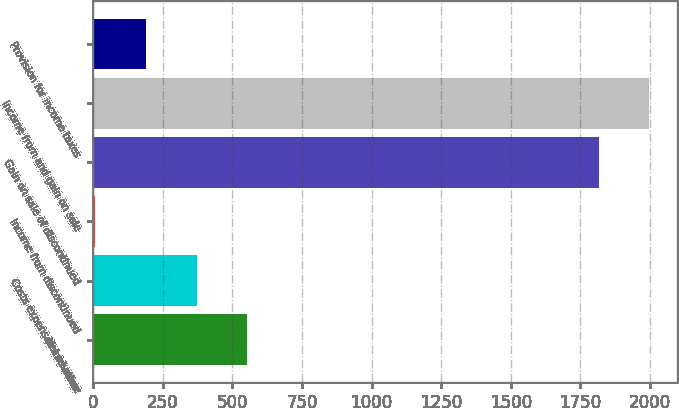Convert chart. <chart><loc_0><loc_0><loc_500><loc_500><bar_chart><fcel>Net revenue<fcel>Costs expenses and other<fcel>Income from discontinued<fcel>Gain on sale of discontinued<fcel>Income from and gain on sale<fcel>Provision for income taxes<nl><fcel>552.8<fcel>371.2<fcel>8<fcel>1816<fcel>1997.6<fcel>189.6<nl></chart> 